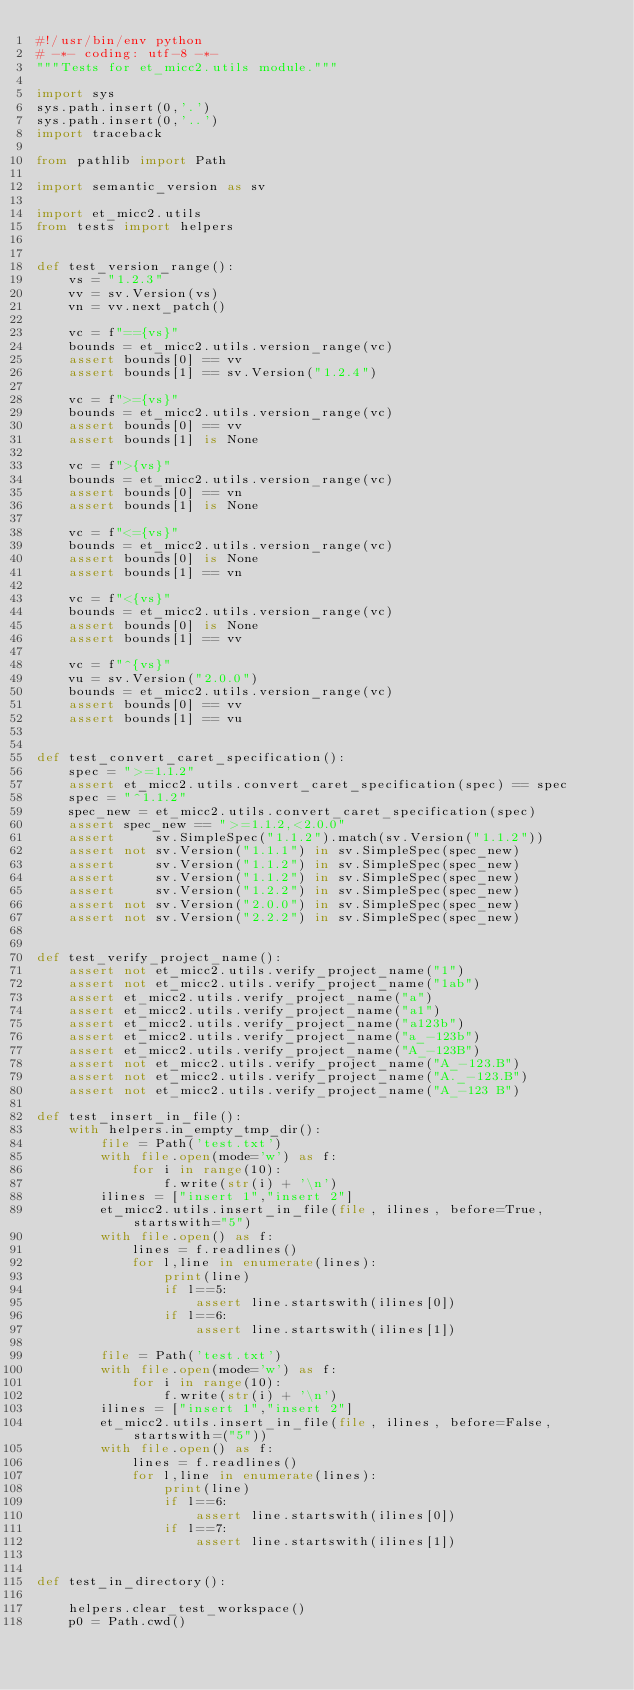<code> <loc_0><loc_0><loc_500><loc_500><_Python_>#!/usr/bin/env python
# -*- coding: utf-8 -*-
"""Tests for et_micc2.utils module."""

import sys
sys.path.insert(0,'.')
sys.path.insert(0,'..')
import traceback

from pathlib import Path

import semantic_version as sv

import et_micc2.utils
from tests import helpers


def test_version_range():
    vs = "1.2.3"
    vv = sv.Version(vs)
    vn = vv.next_patch()
    
    vc = f"=={vs}"
    bounds = et_micc2.utils.version_range(vc)
    assert bounds[0] == vv
    assert bounds[1] == sv.Version("1.2.4")

    vc = f">={vs}"
    bounds = et_micc2.utils.version_range(vc)
    assert bounds[0] == vv
    assert bounds[1] is None

    vc = f">{vs}"
    bounds = et_micc2.utils.version_range(vc)
    assert bounds[0] == vn
    assert bounds[1] is None

    vc = f"<={vs}"
    bounds = et_micc2.utils.version_range(vc)
    assert bounds[0] is None
    assert bounds[1] == vn

    vc = f"<{vs}"
    bounds = et_micc2.utils.version_range(vc)
    assert bounds[0] is None
    assert bounds[1] == vv
    
    vc = f"^{vs}"
    vu = sv.Version("2.0.0")
    bounds = et_micc2.utils.version_range(vc)
    assert bounds[0] == vv
    assert bounds[1] == vu


def test_convert_caret_specification():
    spec = ">=1.1.2"
    assert et_micc2.utils.convert_caret_specification(spec) == spec
    spec = "^1.1.2"
    spec_new = et_micc2.utils.convert_caret_specification(spec)
    assert spec_new == ">=1.1.2,<2.0.0"
    assert     sv.SimpleSpec("1.1.2").match(sv.Version("1.1.2"))
    assert not sv.Version("1.1.1") in sv.SimpleSpec(spec_new)
    assert     sv.Version("1.1.2") in sv.SimpleSpec(spec_new)
    assert     sv.Version("1.1.2") in sv.SimpleSpec(spec_new)
    assert     sv.Version("1.2.2") in sv.SimpleSpec(spec_new)
    assert not sv.Version("2.0.0") in sv.SimpleSpec(spec_new)
    assert not sv.Version("2.2.2") in sv.SimpleSpec(spec_new)


def test_verify_project_name():
    assert not et_micc2.utils.verify_project_name("1")
    assert not et_micc2.utils.verify_project_name("1ab")
    assert et_micc2.utils.verify_project_name("a")
    assert et_micc2.utils.verify_project_name("a1")
    assert et_micc2.utils.verify_project_name("a123b")
    assert et_micc2.utils.verify_project_name("a_-123b")
    assert et_micc2.utils.verify_project_name("A_-123B")
    assert not et_micc2.utils.verify_project_name("A_-123.B")
    assert not et_micc2.utils.verify_project_name("A._-123.B")
    assert not et_micc2.utils.verify_project_name("A_-123 B")
    
def test_insert_in_file():
    with helpers.in_empty_tmp_dir():
        file = Path('test.txt')
        with file.open(mode='w') as f:
            for i in range(10):
                f.write(str(i) + '\n')
        ilines = ["insert 1","insert 2"]
        et_micc2.utils.insert_in_file(file, ilines, before=True, startswith="5")
        with file.open() as f:
            lines = f.readlines()
            for l,line in enumerate(lines):
                print(line)
                if l==5:
                    assert line.startswith(ilines[0])
                if l==6:
                    assert line.startswith(ilines[1])

        file = Path('test.txt')
        with file.open(mode='w') as f:
            for i in range(10):
                f.write(str(i) + '\n')
        ilines = ["insert 1","insert 2"]
        et_micc2.utils.insert_in_file(file, ilines, before=False, startswith=("5"))
        with file.open() as f:
            lines = f.readlines()
            for l,line in enumerate(lines):
                print(line)
                if l==6:
                    assert line.startswith(ilines[0])
                if l==7:
                    assert line.startswith(ilines[1])


def test_in_directory():

    helpers.clear_test_workspace()
    p0 = Path.cwd()
</code> 